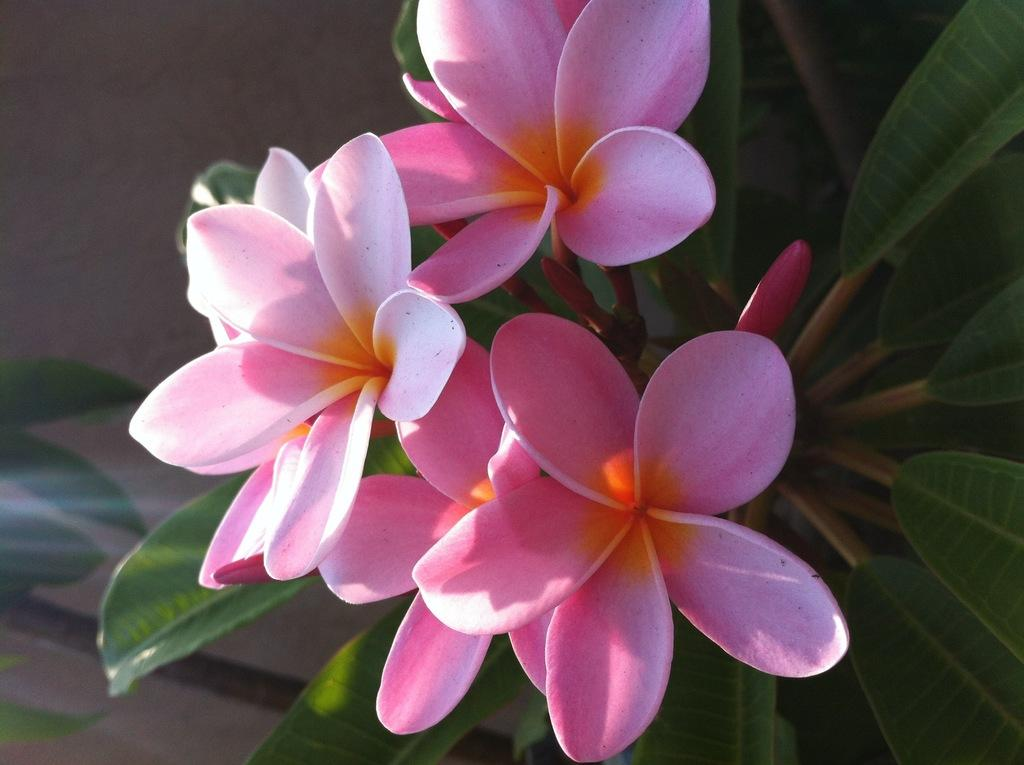What type of living organisms can be seen in the image? There are flowers and plants visible in the image. Can you describe any specific stage of growth for the plants in the image? Yes, there is a bud in the image. How would you describe the background of the image? The background of the image is blurred. What type of horn can be seen on the quince in the image? There is no horn or quince present in the image; it features flowers and plants. What symbol of peace is depicted in the image? There is no symbol of peace depicted in the image; it features flowers and plants. 